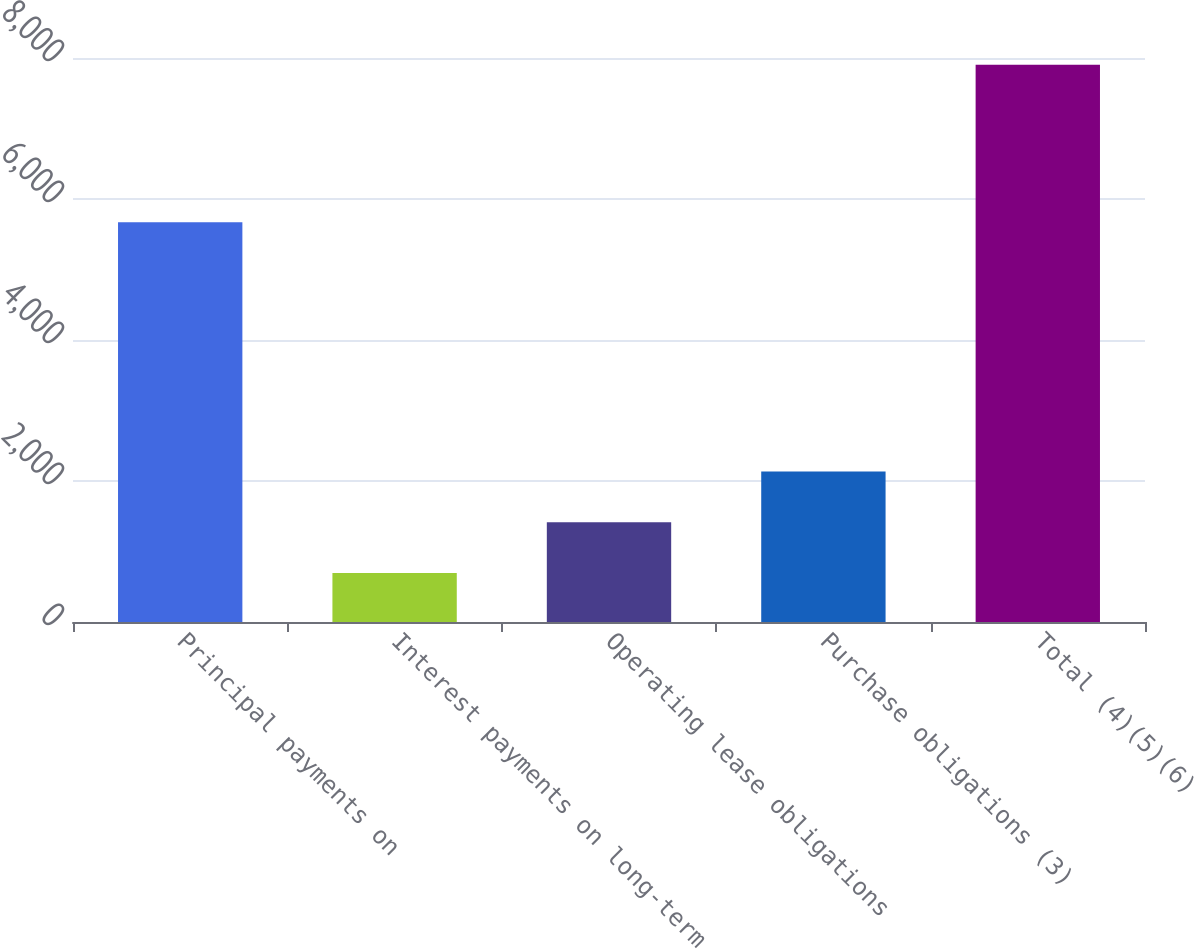Convert chart to OTSL. <chart><loc_0><loc_0><loc_500><loc_500><bar_chart><fcel>Principal payments on<fcel>Interest payments on long-term<fcel>Operating lease obligations<fcel>Purchase obligations (3)<fcel>Total (4)(5)(6)<nl><fcel>5671<fcel>694<fcel>1415.1<fcel>2136.2<fcel>7905<nl></chart> 